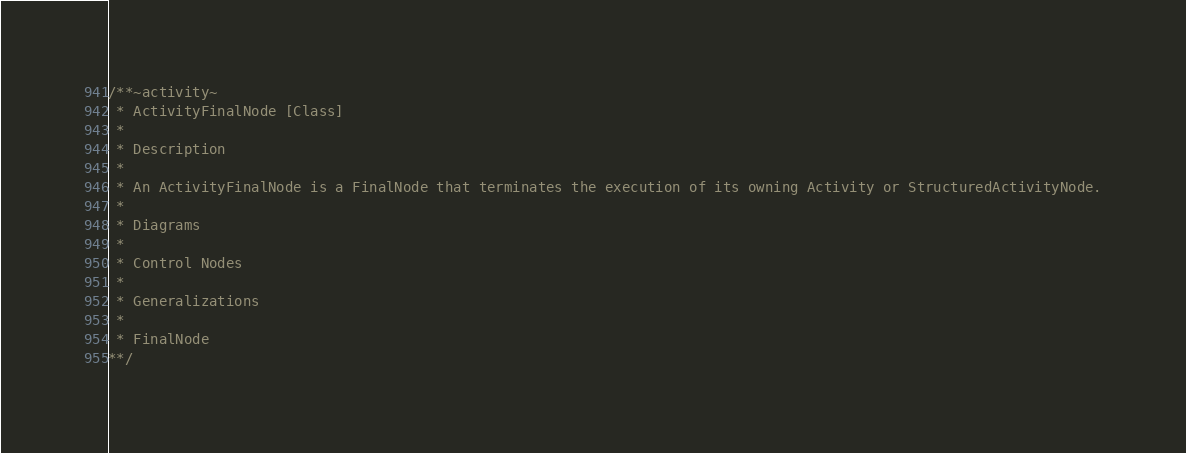<code> <loc_0><loc_0><loc_500><loc_500><_C_>/**~activity~
 * ActivityFinalNode [Class]
 * 
 * Description
 * 
 * An ActivityFinalNode is a FinalNode that terminates the execution of its owning Activity or StructuredActivityNode.
 * 
 * Diagrams
 * 
 * Control Nodes
 * 
 * Generalizations
 * 
 * FinalNode
**/</code> 